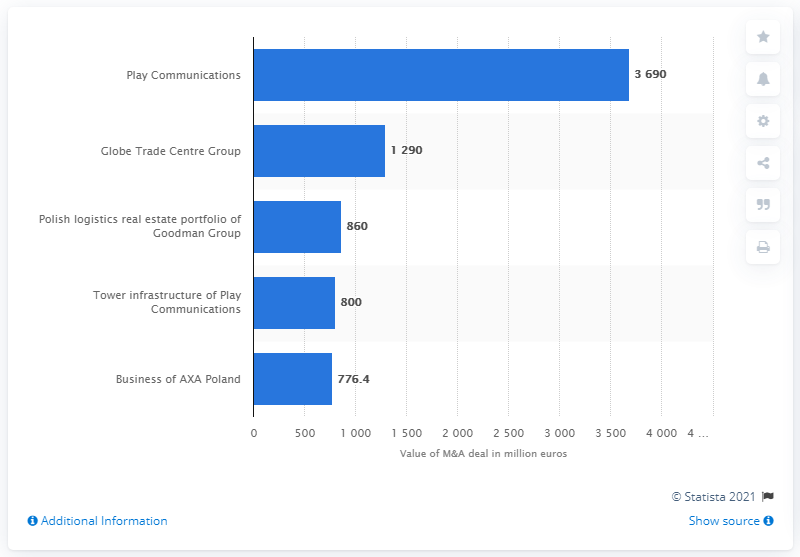List a handful of essential elements in this visual. The largest foreign investment in Poland was worth 3,690 million. Play Communications was the largest foreign investment in Poland. 